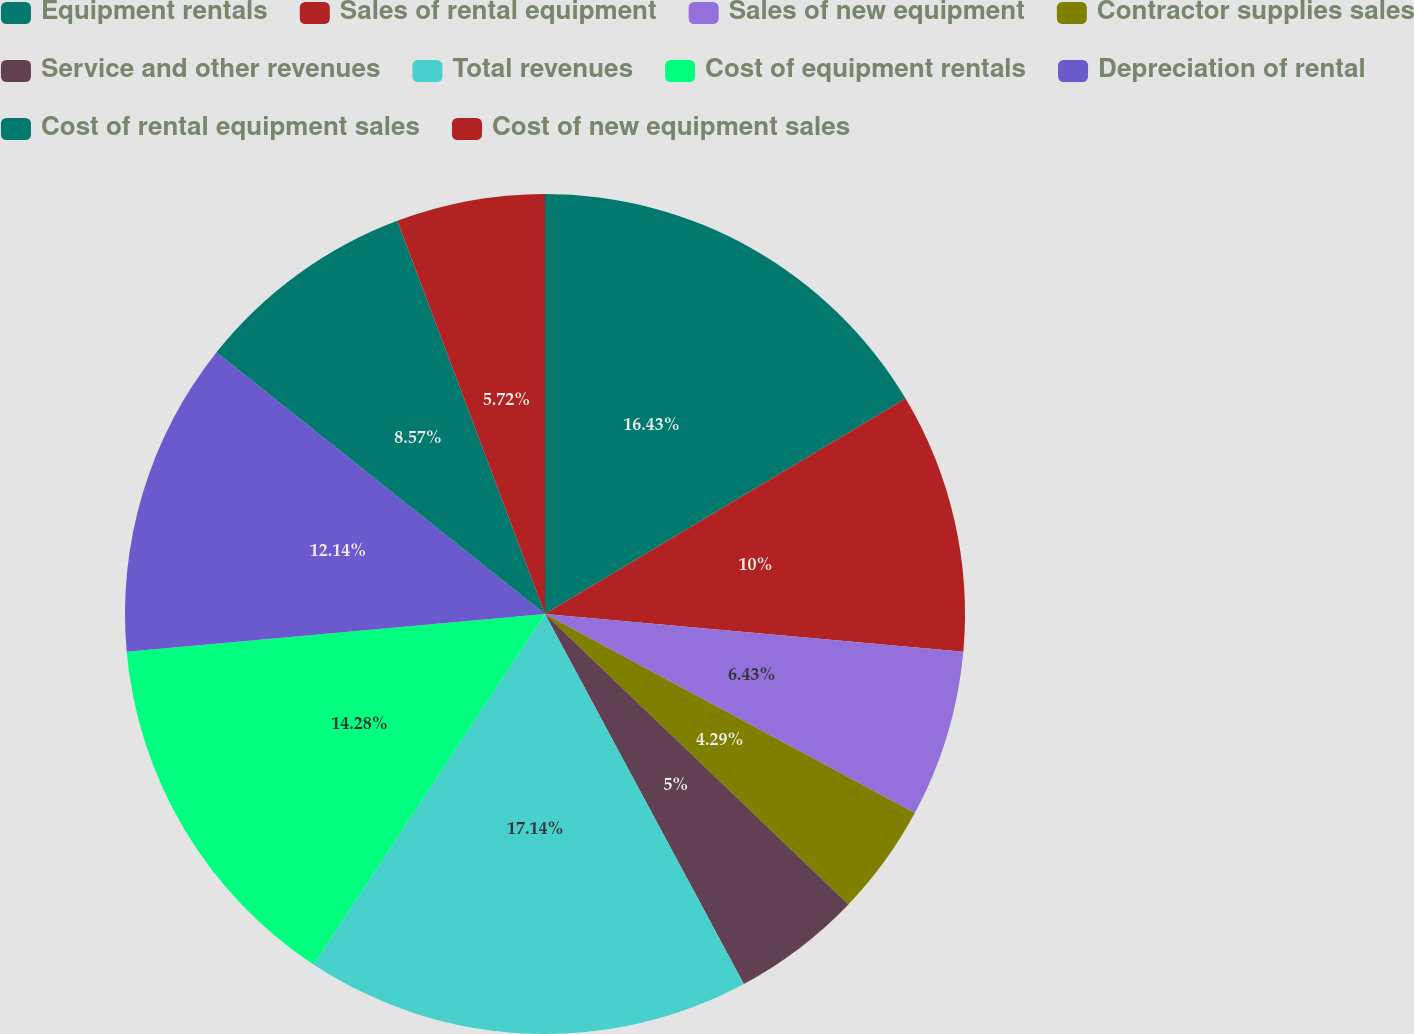Convert chart. <chart><loc_0><loc_0><loc_500><loc_500><pie_chart><fcel>Equipment rentals<fcel>Sales of rental equipment<fcel>Sales of new equipment<fcel>Contractor supplies sales<fcel>Service and other revenues<fcel>Total revenues<fcel>Cost of equipment rentals<fcel>Depreciation of rental<fcel>Cost of rental equipment sales<fcel>Cost of new equipment sales<nl><fcel>16.43%<fcel>10.0%<fcel>6.43%<fcel>4.29%<fcel>5.0%<fcel>17.14%<fcel>14.28%<fcel>12.14%<fcel>8.57%<fcel>5.72%<nl></chart> 